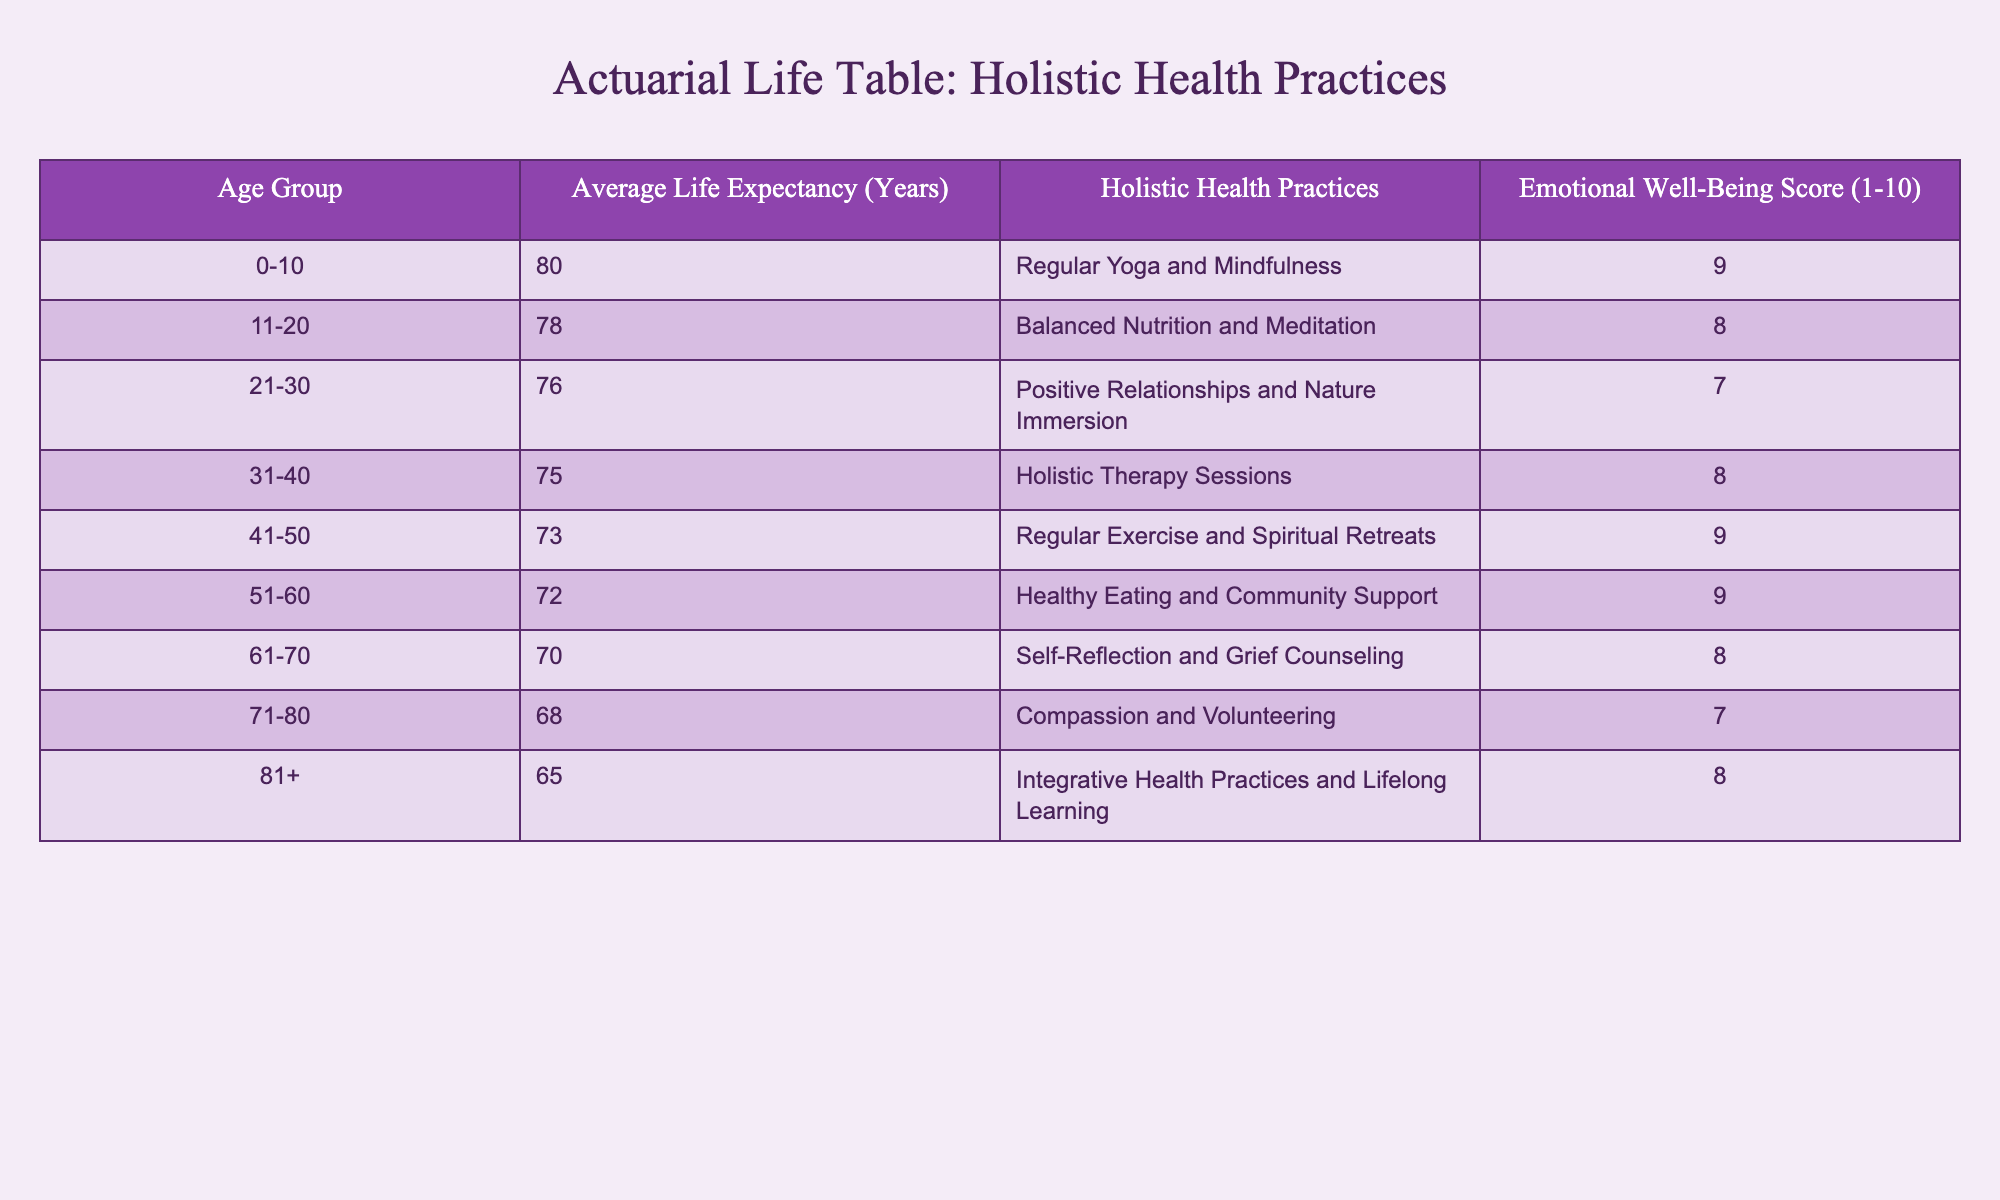What is the average life expectancy for the age group 41-50? The table states that the average life expectancy for the age group 41-50 is 73 years.
Answer: 73 Which age group has the highest Emotional Well-Being Score? By comparing the scores in the table, the age group 0-10 has an Emotional Well-Being Score of 9, which is the highest.
Answer: 0-10 What is the average life expectancy for those aged 61-70 compared to the average for those aged 71-80? The average life expectancy for the 61-70 age group is 70 years, while for 71-80, it is 68 years. The average life expectancy for 61-70 is 2 years more than that of 71-80 (70 - 68 = 2).
Answer: 2 years more Do individuals aged 81+ have higher or lower life expectancy compared to those aged 71-80? The table shows that individuals aged 81+ have an average life expectancy of 65, which is lower than the 68 years for those aged 71-80.
Answer: Lower If we take the holistic health practice "Regular Exercise and Spiritual Retreats," what Emotional Well-Being Score is associated with it? The table indicates that the holistic health practices for the age group 41-50, which includes Regular Exercise and Spiritual Retreats, have an Emotional Well-Being Score of 9.
Answer: 9 What is the sum of the average life expectancies for the age groups 51-60 and 61-70? The average life expectancy for 51-60 is 72 years, and for 61-70, it is 70 years. The sum of these two is 72 + 70 = 142 years.
Answer: 142 Is it true that the average life expectancy decreases with increasing age? Examining the average life expectancies listed for each age group, it is evident that as the age increases, the life expectancy values decrease consistently from 80 to 65 years. Thus, the statement is true.
Answer: True What holistic health practice correlates with the lowest life expectancy? The age group 81+ correlates with the holistic health practice of "Integrative Health Practices and Lifelong Learning", which has the lowest life expectancy of 65 years.
Answer: Integrative Health Practices and Lifelong Learning 